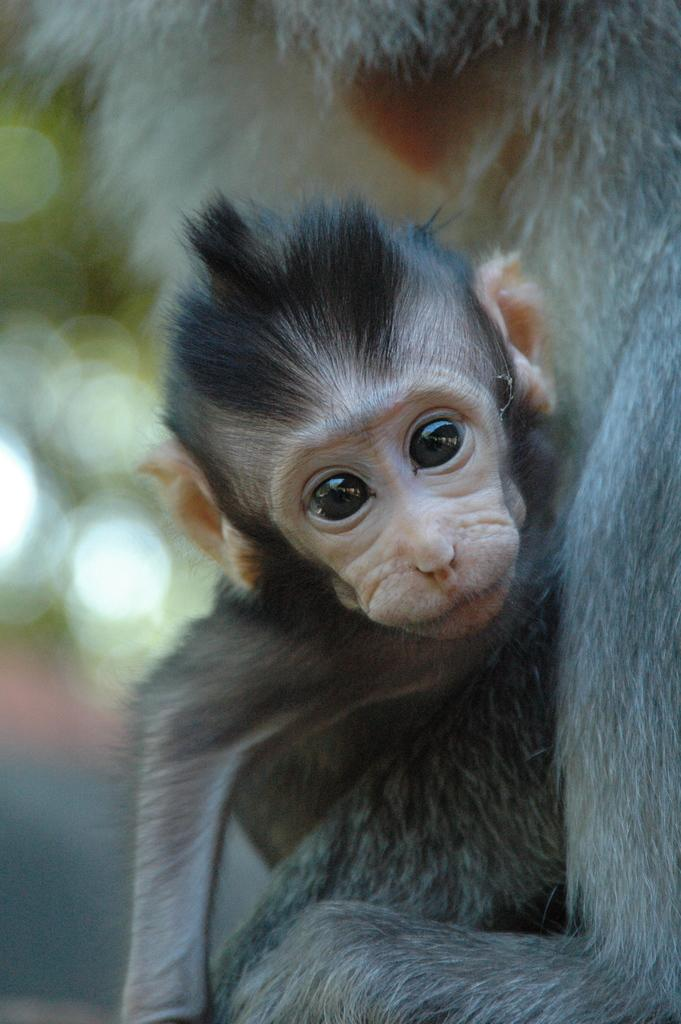What type of animal is in the image? There is a monkey in the image. Can you describe the background of the image? The background of the image is blurred. What type of loss is the monkey experiencing in the image? There is no indication of any loss in the image; the monkey is simply present. 